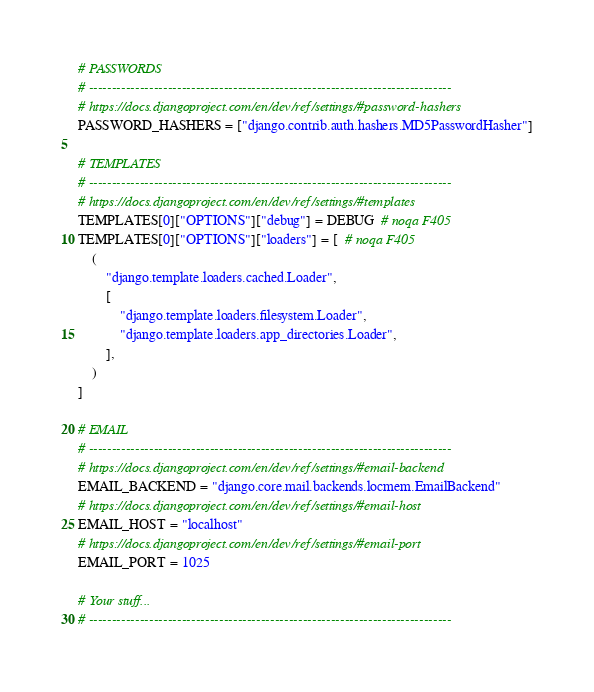<code> <loc_0><loc_0><loc_500><loc_500><_Python_># PASSWORDS
# ------------------------------------------------------------------------------
# https://docs.djangoproject.com/en/dev/ref/settings/#password-hashers
PASSWORD_HASHERS = ["django.contrib.auth.hashers.MD5PasswordHasher"]

# TEMPLATES
# ------------------------------------------------------------------------------
# https://docs.djangoproject.com/en/dev/ref/settings/#templates
TEMPLATES[0]["OPTIONS"]["debug"] = DEBUG  # noqa F405
TEMPLATES[0]["OPTIONS"]["loaders"] = [  # noqa F405
    (
        "django.template.loaders.cached.Loader",
        [
            "django.template.loaders.filesystem.Loader",
            "django.template.loaders.app_directories.Loader",
        ],
    )
]

# EMAIL
# ------------------------------------------------------------------------------
# https://docs.djangoproject.com/en/dev/ref/settings/#email-backend
EMAIL_BACKEND = "django.core.mail.backends.locmem.EmailBackend"
# https://docs.djangoproject.com/en/dev/ref/settings/#email-host
EMAIL_HOST = "localhost"
# https://docs.djangoproject.com/en/dev/ref/settings/#email-port
EMAIL_PORT = 1025

# Your stuff...
# ------------------------------------------------------------------------------
</code> 